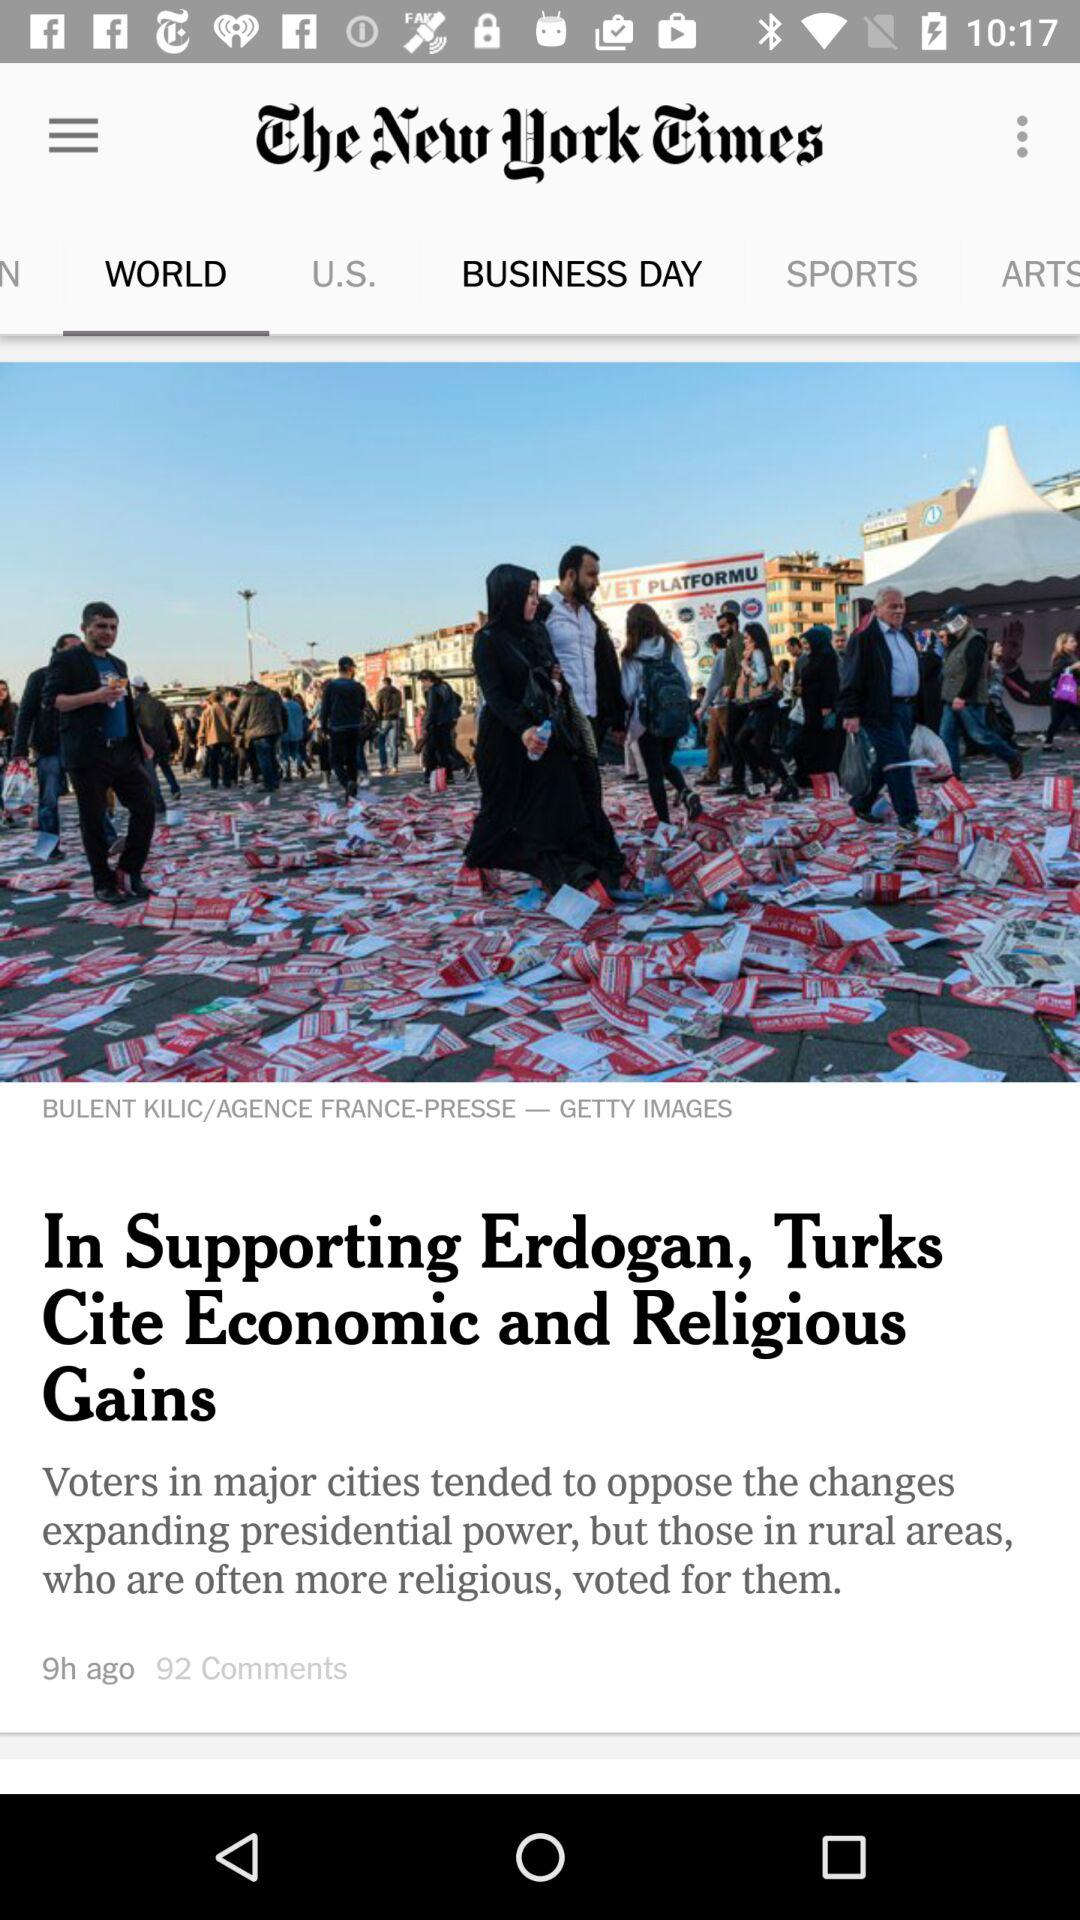Which tab is selected? The selected tab is "WORLD". 